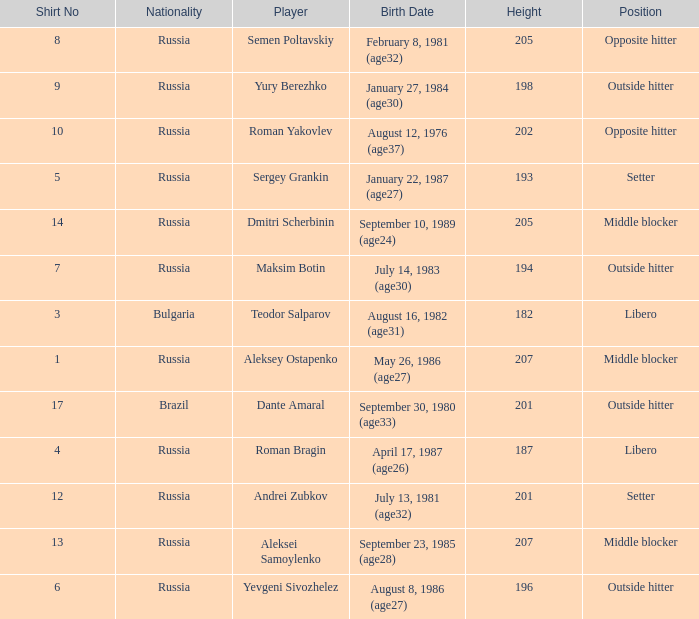What is Roman Bragin's position?  Libero. 